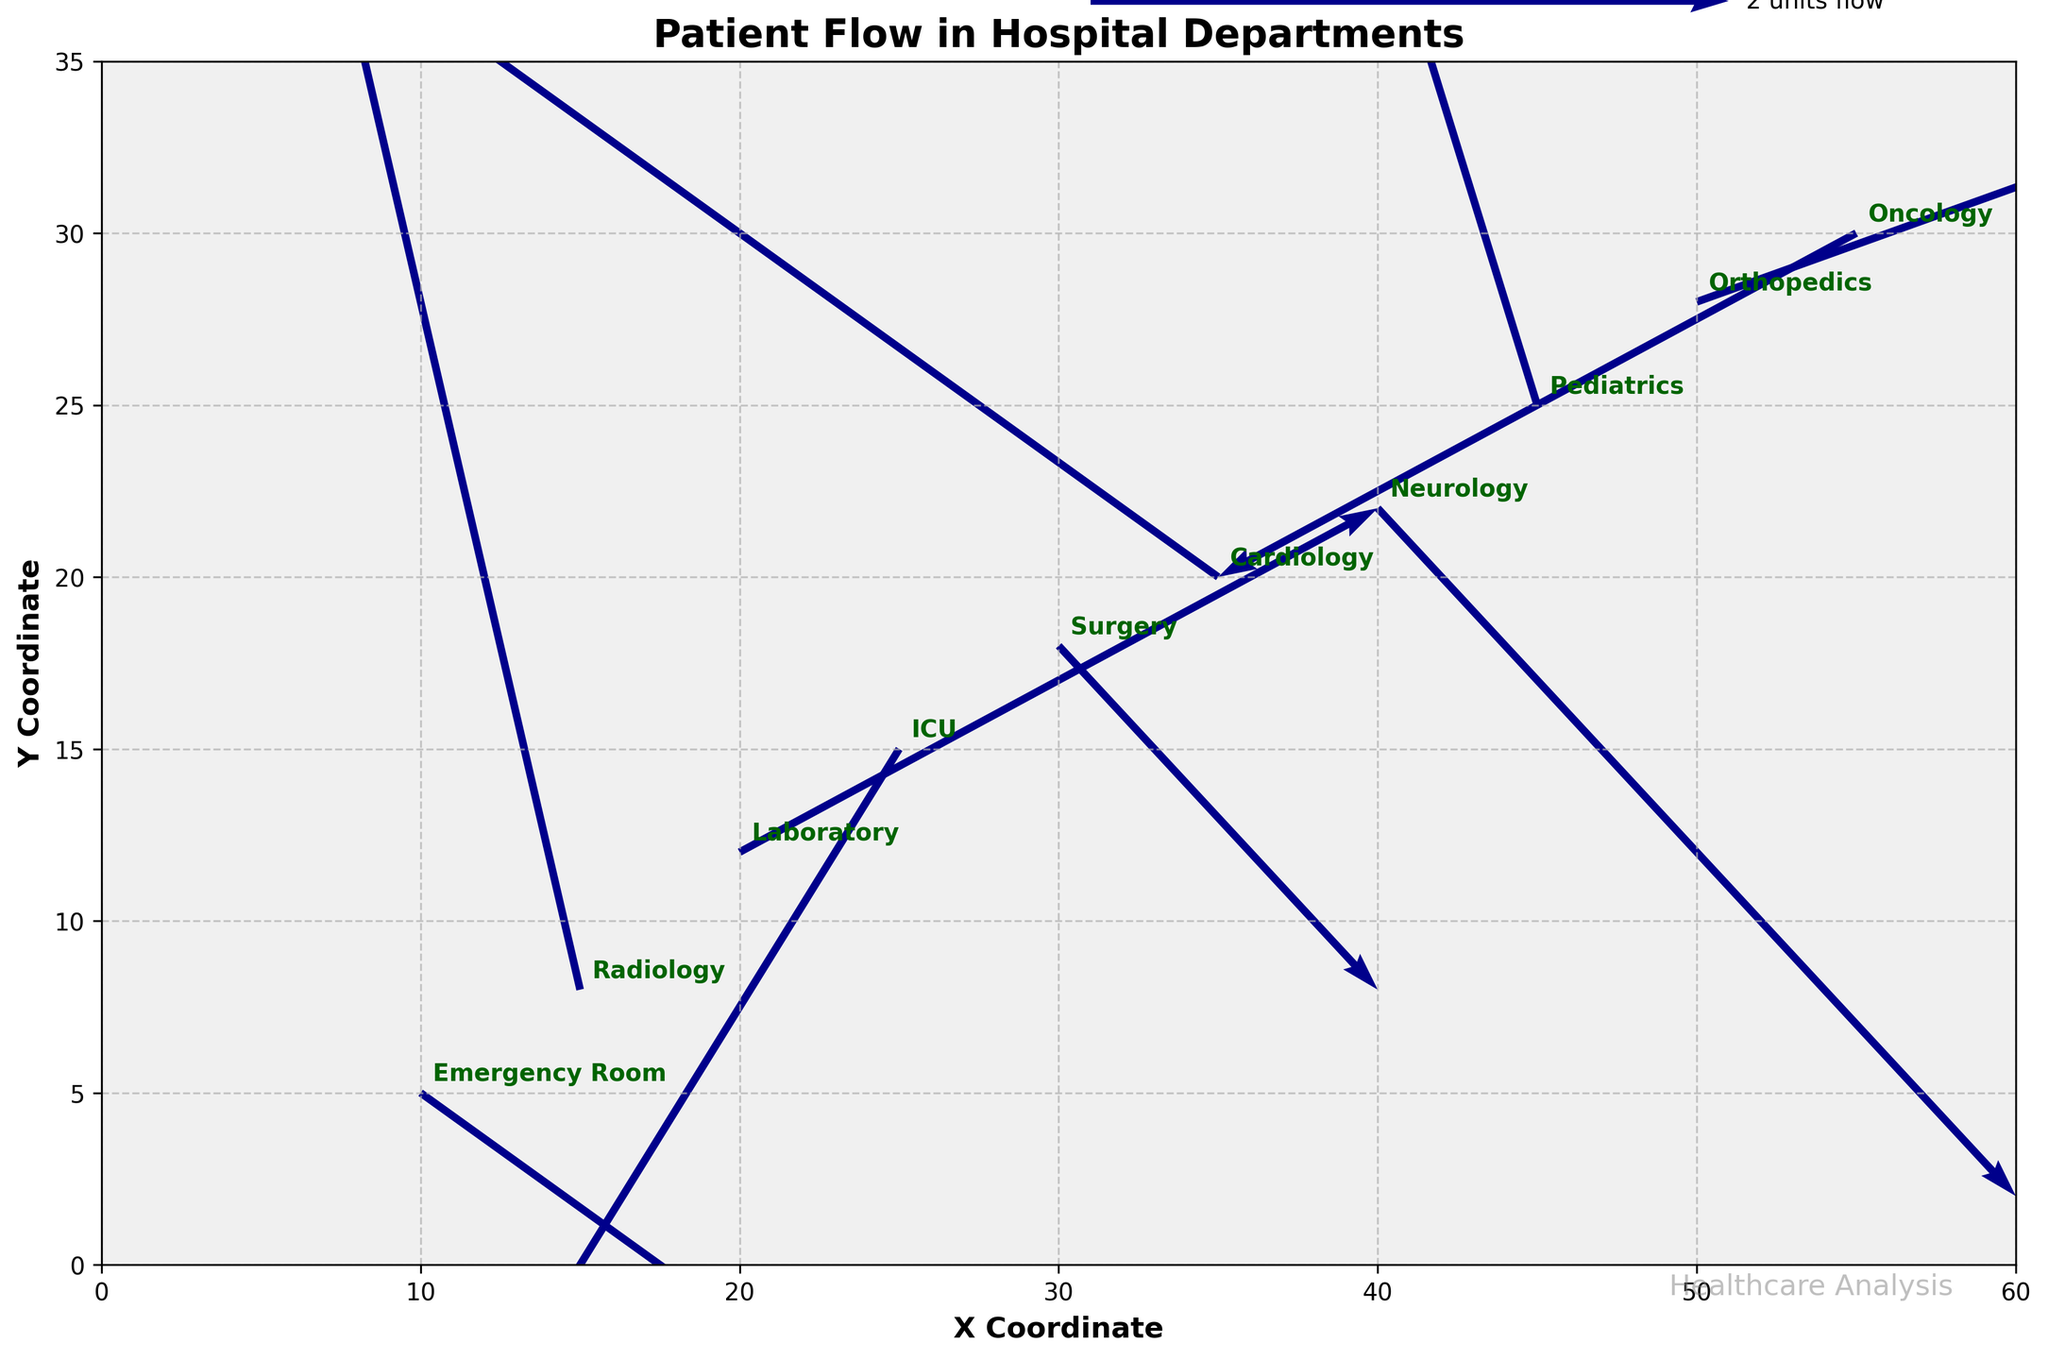How many departments are represented in the plot? The plot shows labels for each department next to their corresponding arrows. Counting these labels will give the total number of departments. There are 10 unique department labels visible in the figure.
Answer: 10 What direction is the flow in the Emergency Room? Looking at the arrow associated with the Emergency Room, the arrow points to the right and slightly downwards. This indicates a movement with coordinates (3, -2).
Answer: Right and Downwards Which department has the longest flow vector? The length of the flow vectors corresponds to the magnitude of the U and V values. The Orthopedics department has a (3, 1) vector which has the highest magnitude among all the vectors.
Answer: Orthopedics Are there more departments with overall positive movements (both u and v) or negative movements? We'll count the departments with both positive u and v values versus those with both negative u and v values. Positive: Radiology, Orthopedics (2). Negative: ICU, Oncology (2). The total number of departments with overall positive and negative movements is equal.
Answer: Equal Which department is located at the highest y-coordinate? The y-axis coordinate tells the vertical position in the figure. The department located at the highest y-coordinate (30) is Oncology.
Answer: Oncology What department has a flow direction towards the upper right (positive u and positive v)? Identifying arrows with both u and v positive, we find that Radiology meets this condition.
Answer: Radiology What is the flow magnitude for the Cardioloogy department? The flow vector is (-3, 2). To calculate the magnitude: sqrt((-3)^2 + (2)^2) = sqrt(9 + 4) = sqrt(13) ≈ 3.61.
Answer: Approximately 3.61 How does the flow direction of Neurology compare to Pediatrics? The flow direction of Neurology is (2, -2) meaning right and down. Pediatrics has a flow direction of (-1, 3) meaning left and up. The flow directions are opposite in both components.
Answer: Opposite Which department has the most downward movement? Downward movement is indicated by the most negative v-value. ICU has the v-value of -3, which is the most downward.
Answer: ICU 